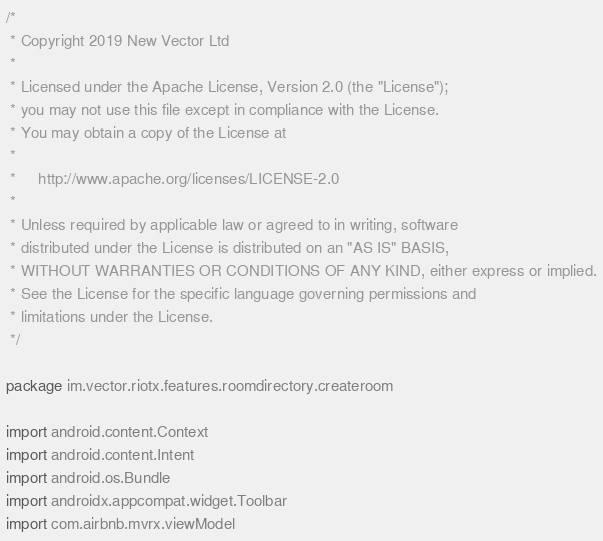Convert code to text. <code><loc_0><loc_0><loc_500><loc_500><_Kotlin_>/*
 * Copyright 2019 New Vector Ltd
 *
 * Licensed under the Apache License, Version 2.0 (the "License");
 * you may not use this file except in compliance with the License.
 * You may obtain a copy of the License at
 *
 *     http://www.apache.org/licenses/LICENSE-2.0
 *
 * Unless required by applicable law or agreed to in writing, software
 * distributed under the License is distributed on an "AS IS" BASIS,
 * WITHOUT WARRANTIES OR CONDITIONS OF ANY KIND, either express or implied.
 * See the License for the specific language governing permissions and
 * limitations under the License.
 */

package im.vector.riotx.features.roomdirectory.createroom

import android.content.Context
import android.content.Intent
import android.os.Bundle
import androidx.appcompat.widget.Toolbar
import com.airbnb.mvrx.viewModel</code> 